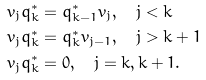Convert formula to latex. <formula><loc_0><loc_0><loc_500><loc_500>v _ { j } q _ { k } ^ { * } & = q _ { k - 1 } ^ { * } v _ { j } , \quad j < k \\ v _ { j } q _ { k } ^ { * } & = q _ { k } ^ { * } v _ { j - 1 } , \quad j > k + 1 \\ v _ { j } q _ { k } ^ { * } & = 0 , \quad j = k , k + 1 .</formula> 